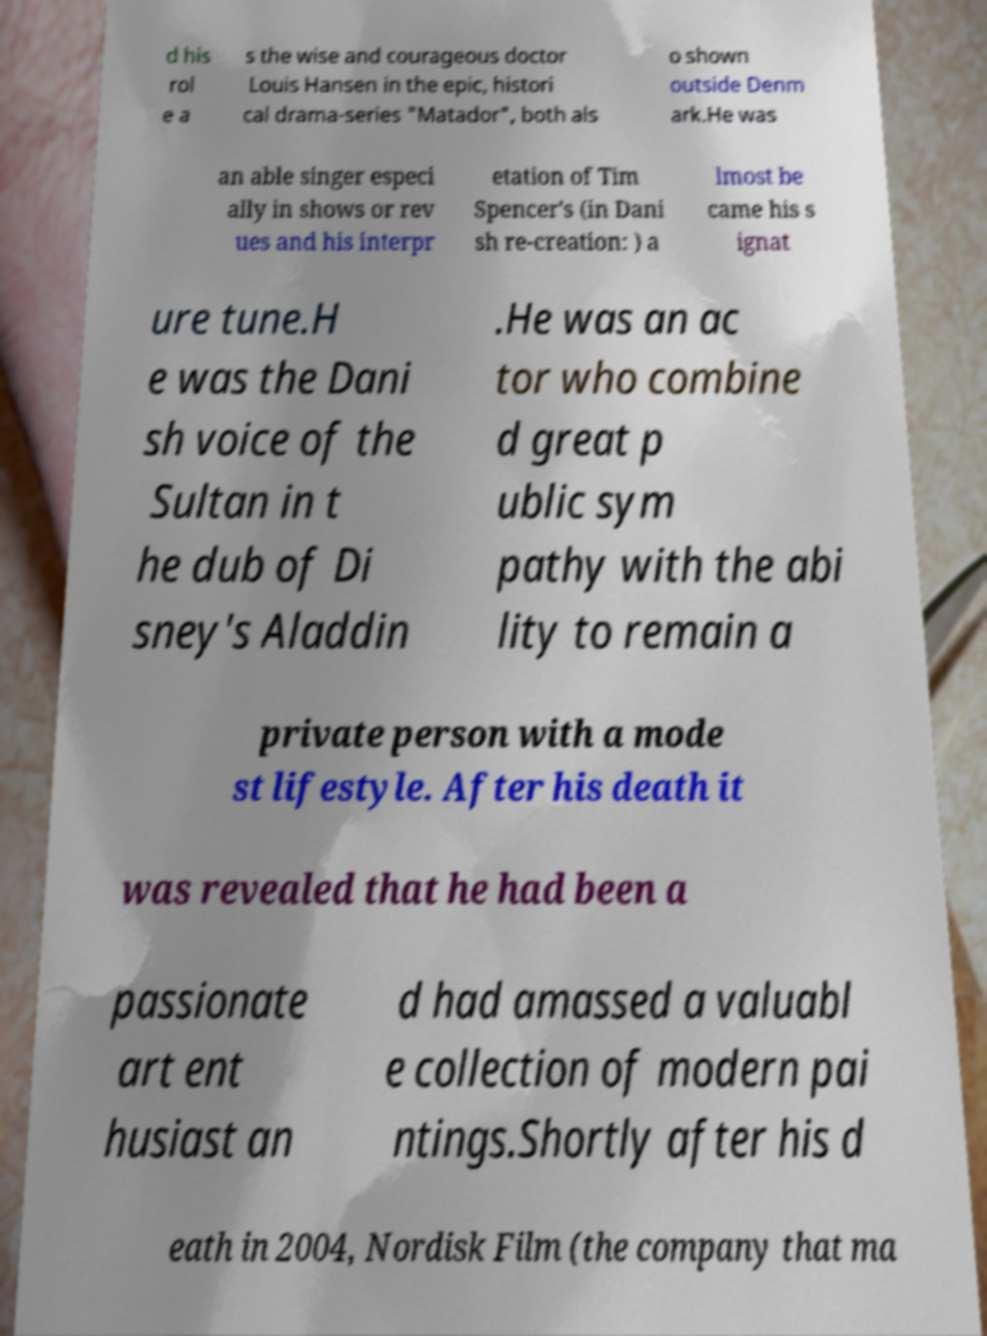Can you accurately transcribe the text from the provided image for me? d his rol e a s the wise and courageous doctor Louis Hansen in the epic, histori cal drama-series "Matador", both als o shown outside Denm ark.He was an able singer especi ally in shows or rev ues and his interpr etation of Tim Spencer's (in Dani sh re-creation: ) a lmost be came his s ignat ure tune.H e was the Dani sh voice of the Sultan in t he dub of Di sney's Aladdin .He was an ac tor who combine d great p ublic sym pathy with the abi lity to remain a private person with a mode st lifestyle. After his death it was revealed that he had been a passionate art ent husiast an d had amassed a valuabl e collection of modern pai ntings.Shortly after his d eath in 2004, Nordisk Film (the company that ma 